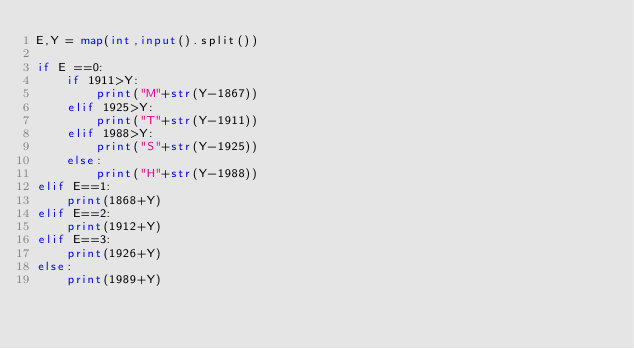Convert code to text. <code><loc_0><loc_0><loc_500><loc_500><_Python_>E,Y = map(int,input().split())

if E ==0:
    if 1911>Y:
        print("M"+str(Y-1867))
    elif 1925>Y:
        print("T"+str(Y-1911))
    elif 1988>Y:
        print("S"+str(Y-1925))
    else:
        print("H"+str(Y-1988))
elif E==1:
    print(1868+Y)
elif E==2:
    print(1912+Y)
elif E==3:
    print(1926+Y)
else:
    print(1989+Y)

</code> 